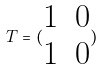<formula> <loc_0><loc_0><loc_500><loc_500>T = ( \begin{matrix} 1 & 0 \\ 1 & 0 \end{matrix} )</formula> 